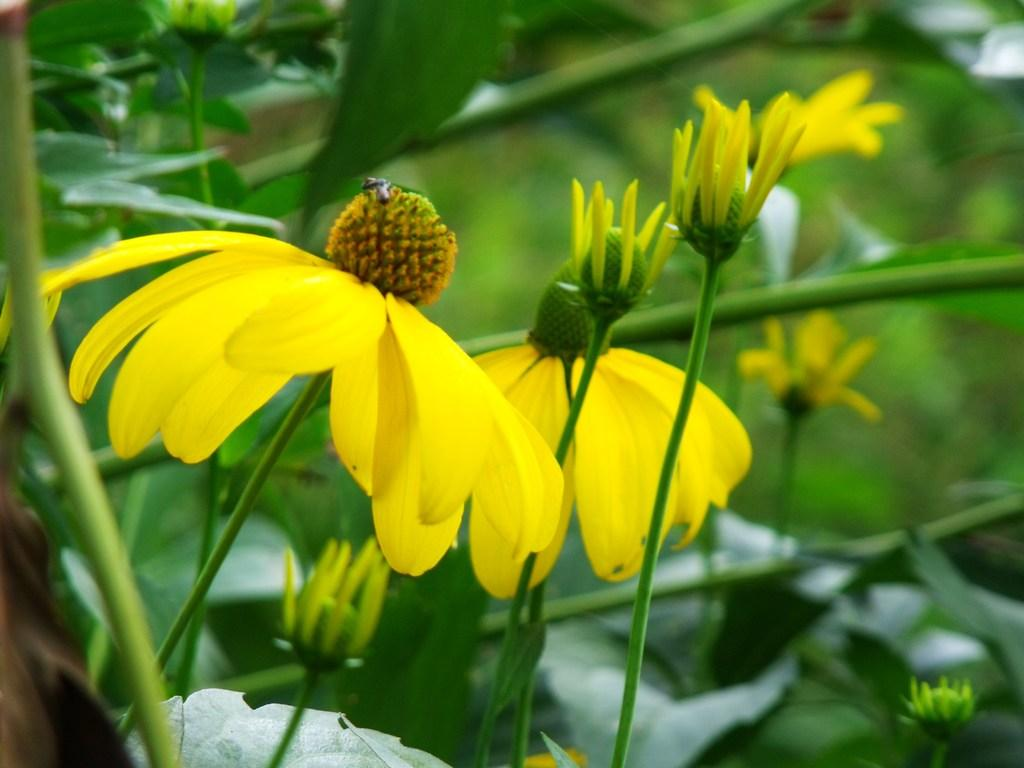What color are the flowers in the image? The flowers in the image are yellow. Do the flowers have any visible parts besides the petals? Yes, the flowers have stems. Where are the flowers located in the image? The flowers are in the middle of the image. What type of art can be seen on the base of the flowers in the image? There is no art or base present in the image; it features yellow flowers with stems. 